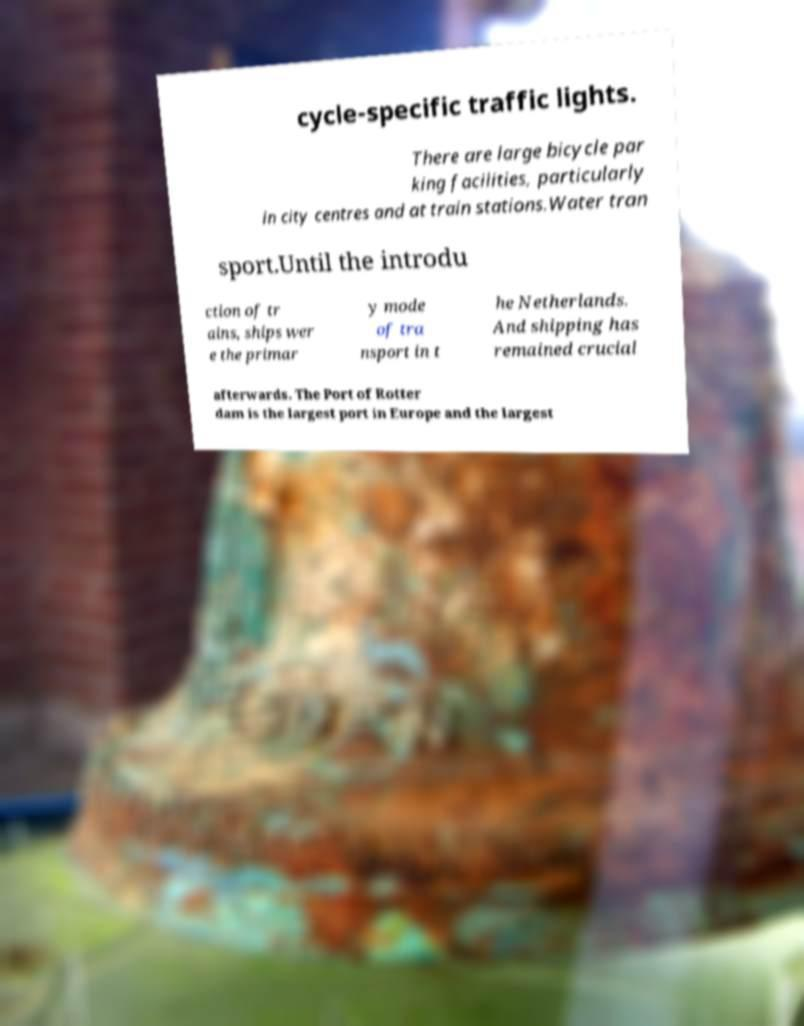Could you extract and type out the text from this image? cycle-specific traffic lights. There are large bicycle par king facilities, particularly in city centres and at train stations.Water tran sport.Until the introdu ction of tr ains, ships wer e the primar y mode of tra nsport in t he Netherlands. And shipping has remained crucial afterwards. The Port of Rotter dam is the largest port in Europe and the largest 